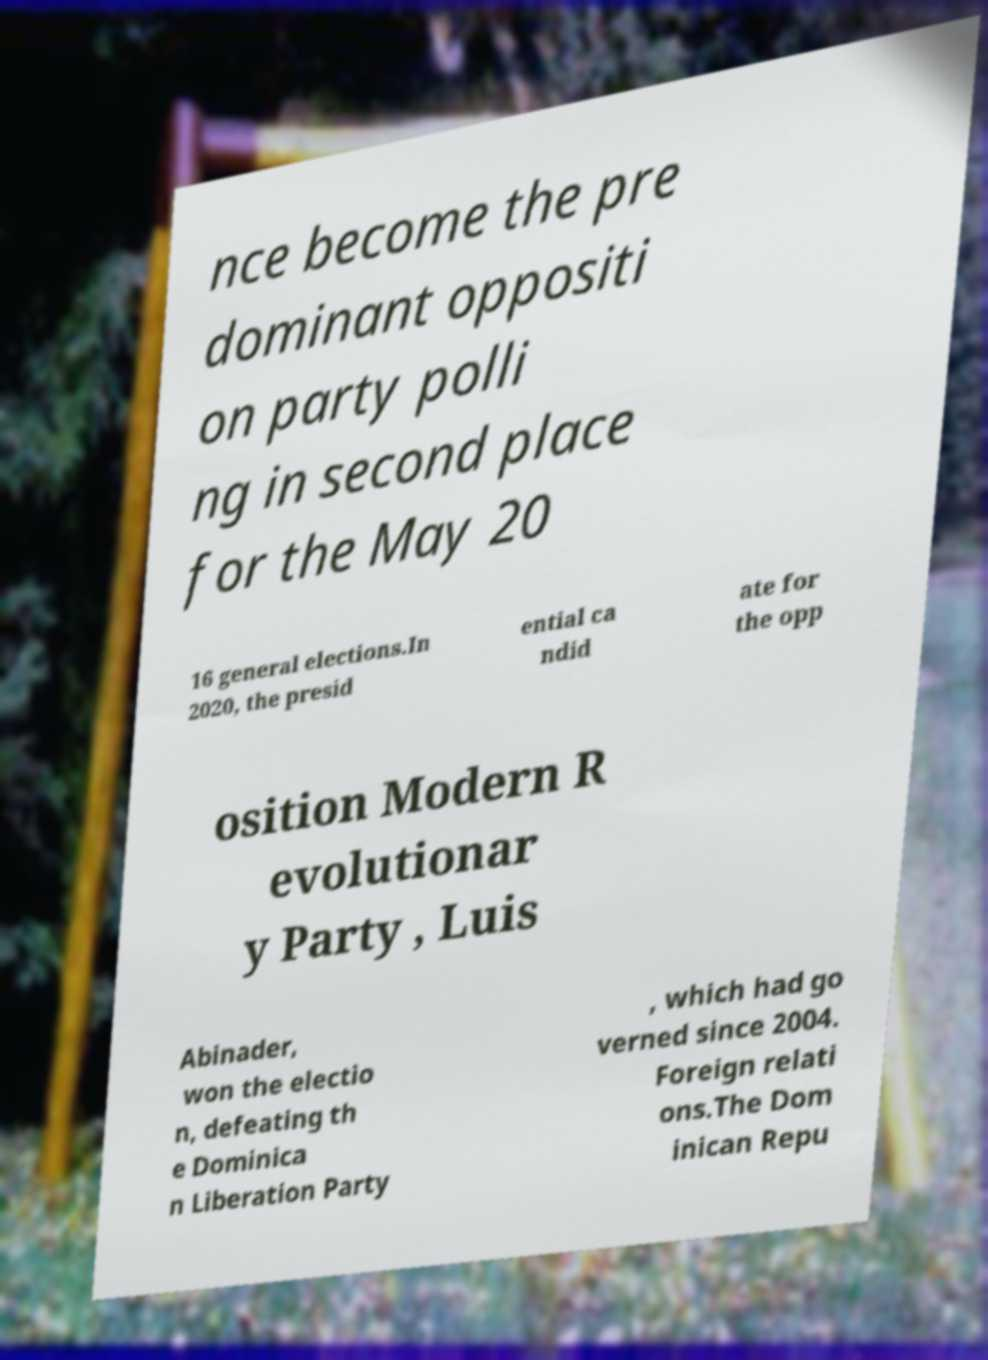There's text embedded in this image that I need extracted. Can you transcribe it verbatim? nce become the pre dominant oppositi on party polli ng in second place for the May 20 16 general elections.In 2020, the presid ential ca ndid ate for the opp osition Modern R evolutionar y Party , Luis Abinader, won the electio n, defeating th e Dominica n Liberation Party , which had go verned since 2004. Foreign relati ons.The Dom inican Repu 